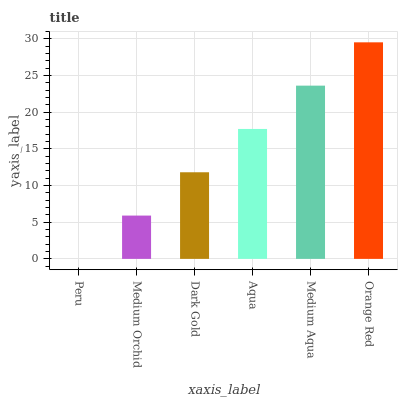Is Peru the minimum?
Answer yes or no. Yes. Is Orange Red the maximum?
Answer yes or no. Yes. Is Medium Orchid the minimum?
Answer yes or no. No. Is Medium Orchid the maximum?
Answer yes or no. No. Is Medium Orchid greater than Peru?
Answer yes or no. Yes. Is Peru less than Medium Orchid?
Answer yes or no. Yes. Is Peru greater than Medium Orchid?
Answer yes or no. No. Is Medium Orchid less than Peru?
Answer yes or no. No. Is Aqua the high median?
Answer yes or no. Yes. Is Dark Gold the low median?
Answer yes or no. Yes. Is Orange Red the high median?
Answer yes or no. No. Is Medium Aqua the low median?
Answer yes or no. No. 